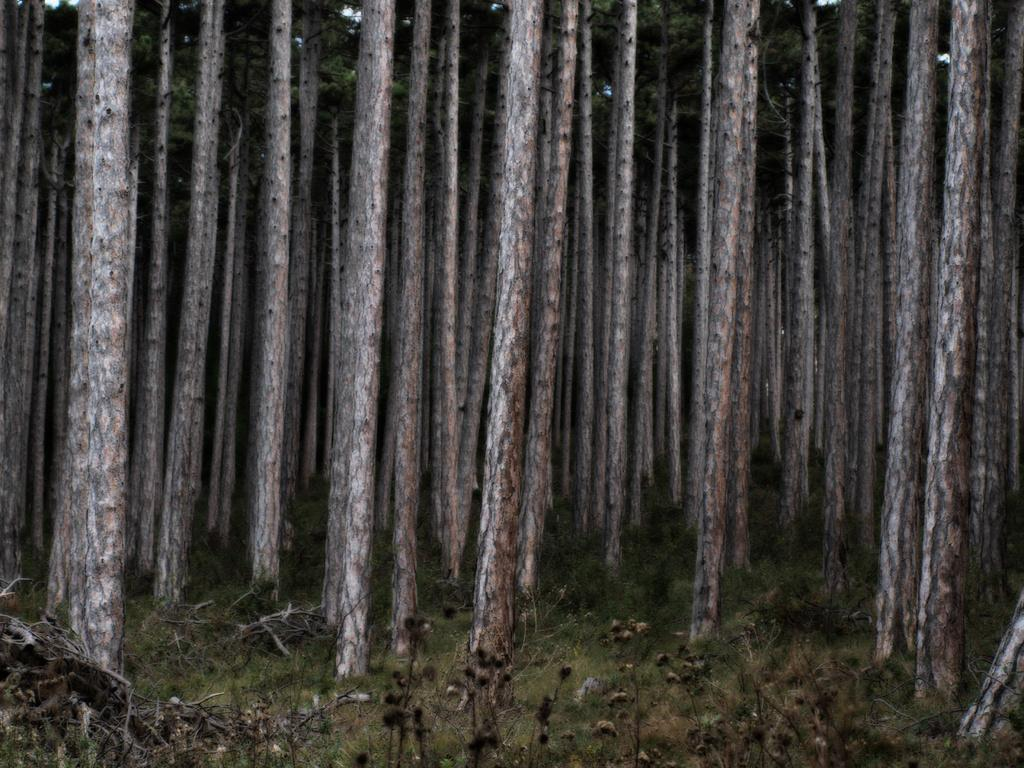What type of vegetation can be seen in the image? There are trees in the image. What type of ground cover is visible at the bottom of the image? There is grass at the bottom of the image. What other type of plant is present in the foreground of the image? There are plants in the foreground of the image. What color is the shirt worn by the soap in the image? There is no shirt or soap present in the image; it features trees, grass, and plants. 